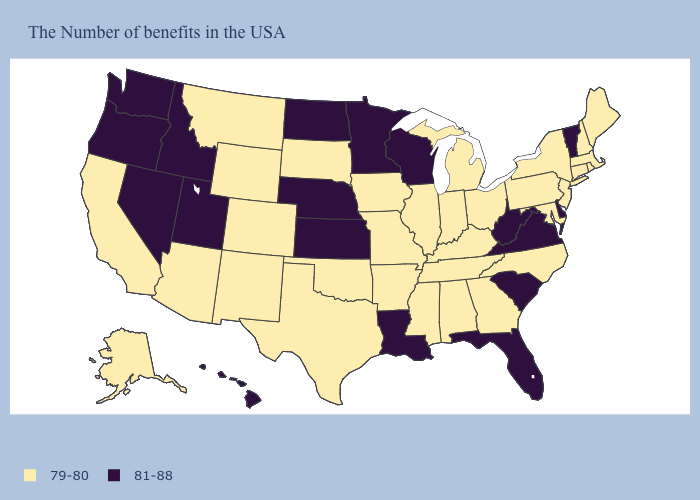What is the highest value in states that border Tennessee?
Quick response, please. 81-88. Does South Dakota have the highest value in the USA?
Be succinct. No. Name the states that have a value in the range 79-80?
Concise answer only. Maine, Massachusetts, Rhode Island, New Hampshire, Connecticut, New York, New Jersey, Maryland, Pennsylvania, North Carolina, Ohio, Georgia, Michigan, Kentucky, Indiana, Alabama, Tennessee, Illinois, Mississippi, Missouri, Arkansas, Iowa, Oklahoma, Texas, South Dakota, Wyoming, Colorado, New Mexico, Montana, Arizona, California, Alaska. What is the value of Hawaii?
Answer briefly. 81-88. What is the value of New Hampshire?
Answer briefly. 79-80. What is the lowest value in states that border Colorado?
Quick response, please. 79-80. Among the states that border Ohio , which have the highest value?
Concise answer only. West Virginia. What is the highest value in the Northeast ?
Concise answer only. 81-88. What is the lowest value in the Northeast?
Write a very short answer. 79-80. What is the value of Texas?
Write a very short answer. 79-80. What is the value of Illinois?
Quick response, please. 79-80. Does the map have missing data?
Be succinct. No. Does West Virginia have the same value as Oregon?
Be succinct. Yes. Does the map have missing data?
Answer briefly. No. Which states have the lowest value in the USA?
Quick response, please. Maine, Massachusetts, Rhode Island, New Hampshire, Connecticut, New York, New Jersey, Maryland, Pennsylvania, North Carolina, Ohio, Georgia, Michigan, Kentucky, Indiana, Alabama, Tennessee, Illinois, Mississippi, Missouri, Arkansas, Iowa, Oklahoma, Texas, South Dakota, Wyoming, Colorado, New Mexico, Montana, Arizona, California, Alaska. 